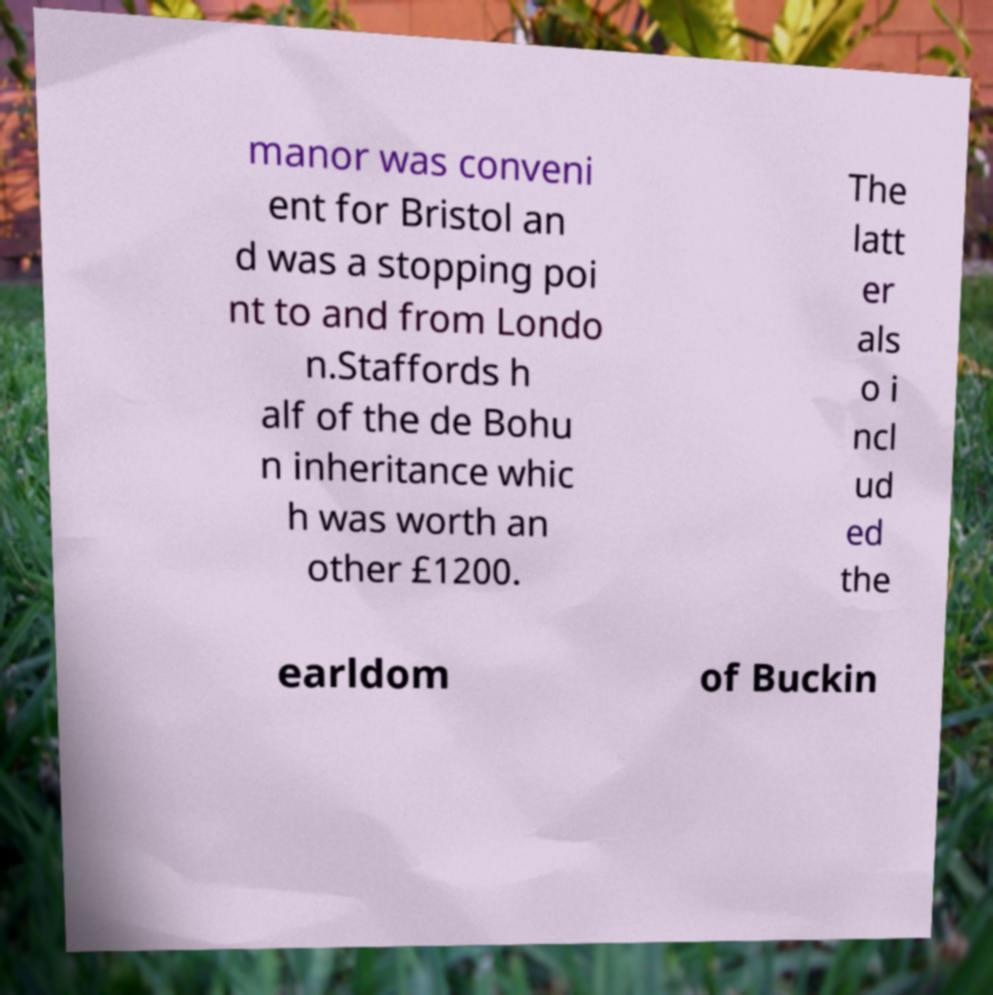Could you extract and type out the text from this image? manor was conveni ent for Bristol an d was a stopping poi nt to and from Londo n.Staffords h alf of the de Bohu n inheritance whic h was worth an other £1200. The latt er als o i ncl ud ed the earldom of Buckin 